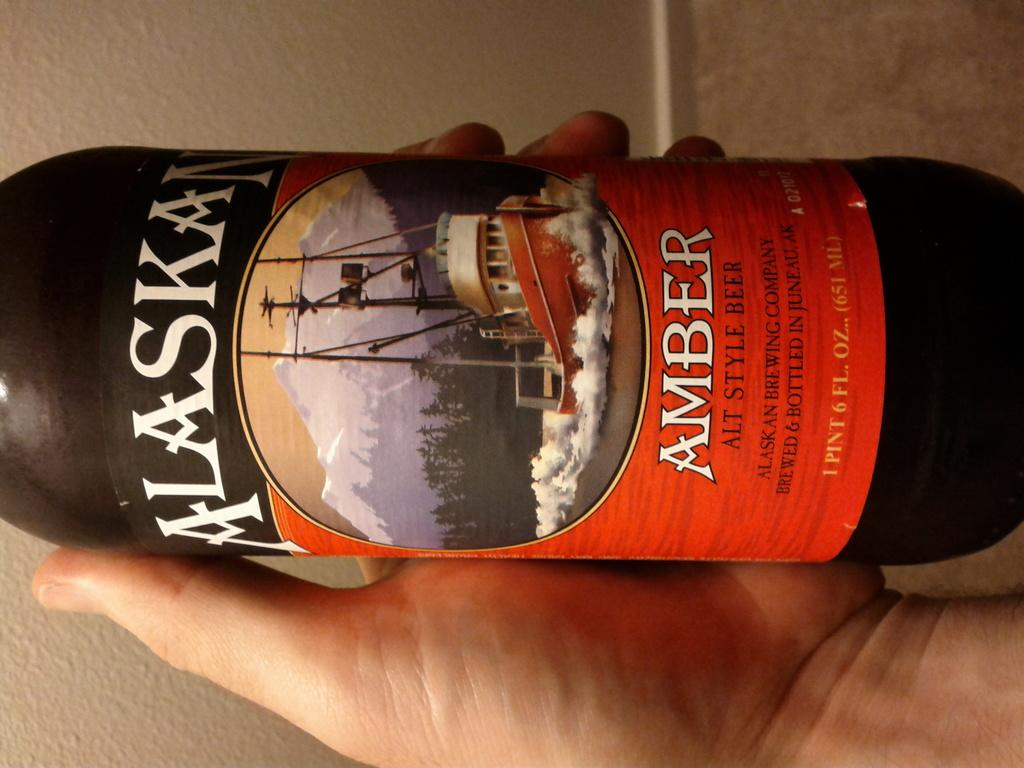<image>
Create a compact narrative representing the image presented. the word Amber is on the bottle of Alaska 